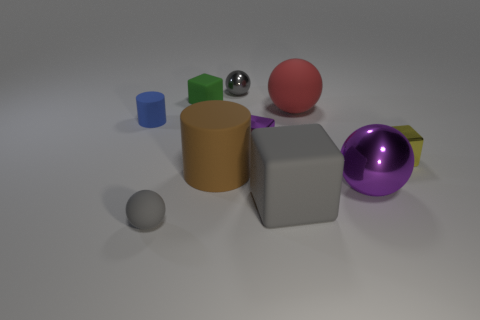The metallic sphere that is the same color as the big matte cube is what size?
Make the answer very short. Small. Are there any other things that have the same material as the small green object?
Your answer should be compact. Yes. Does the small gray object to the left of the big cylinder have the same shape as the big matte object that is in front of the large brown rubber cylinder?
Your answer should be very brief. No. Are there any large metallic objects?
Keep it short and to the point. Yes. What is the color of the shiny ball that is the same size as the gray matte cube?
Offer a very short reply. Purple. How many tiny purple metal things have the same shape as the large gray thing?
Offer a very short reply. 1. Does the sphere that is behind the small green rubber object have the same material as the gray block?
Your answer should be very brief. No. How many cubes are either yellow objects or purple shiny objects?
Offer a very short reply. 2. The gray object that is in front of the rubber cube that is in front of the cube on the right side of the large cube is what shape?
Make the answer very short. Sphere. What shape is the thing that is the same color as the big shiny ball?
Your answer should be compact. Cube. 